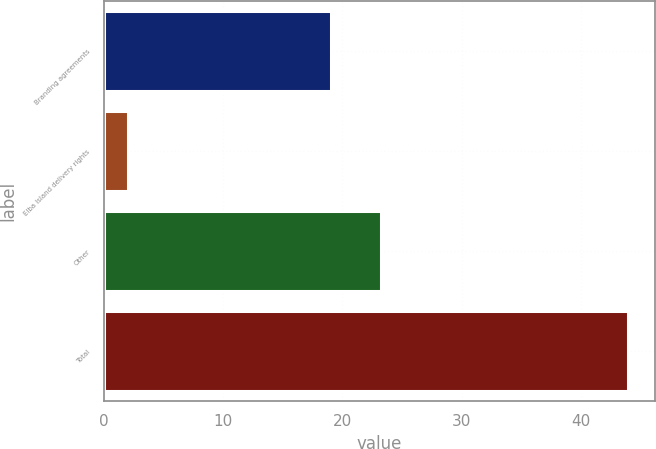Convert chart to OTSL. <chart><loc_0><loc_0><loc_500><loc_500><bar_chart><fcel>Branding agreements<fcel>Elba Island delivery rights<fcel>Other<fcel>Total<nl><fcel>19<fcel>2<fcel>23.2<fcel>44<nl></chart> 